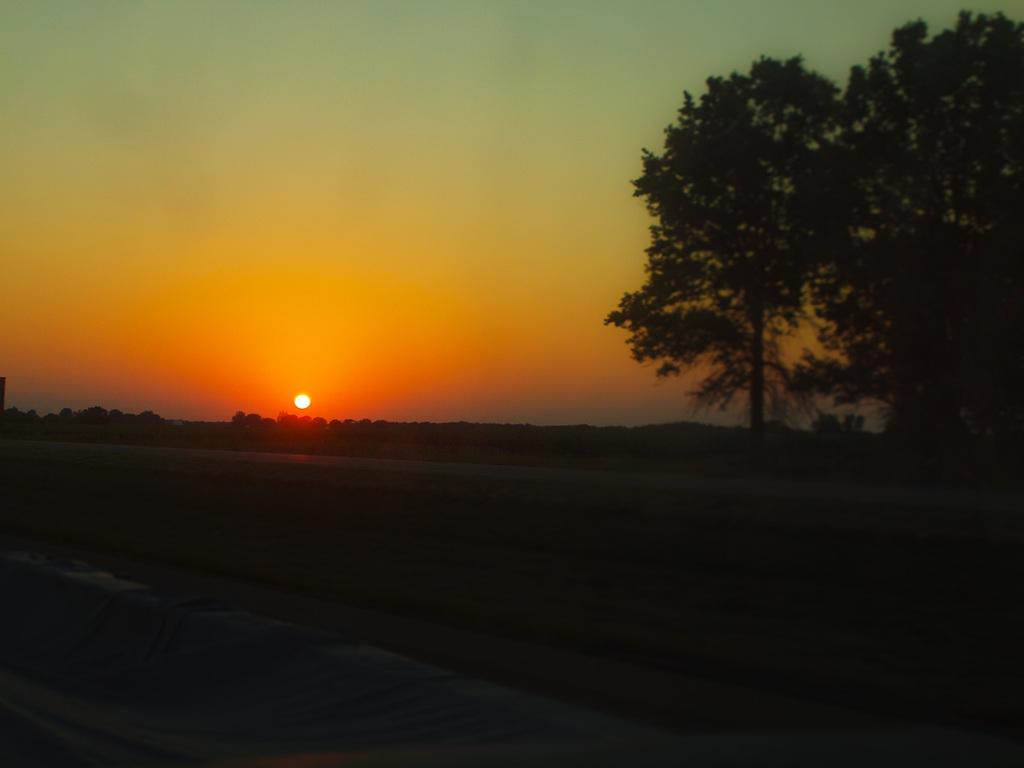What is the overall lighting condition in the image? The image is dark. What type of natural elements can be seen in the image? There are trees in the image. What celestial body is visible in the background of the image? The sun is visible in the background of the image. What else can be seen in the background of the image? The sky is visible in the background of the image. What type of jam is being spread on the mother's face in the image? There is no mother or jam present in the image; it features trees, a dark lighting condition, and the sun visible in the background. 